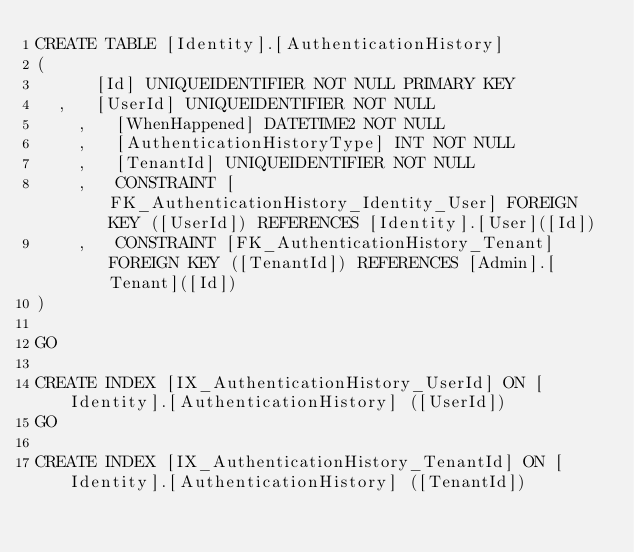Convert code to text. <code><loc_0><loc_0><loc_500><loc_500><_SQL_>CREATE TABLE [Identity].[AuthenticationHistory]
(
	    [Id] UNIQUEIDENTIFIER NOT NULL PRIMARY KEY
	,   [UserId] UNIQUEIDENTIFIER NOT NULL
    ,   [WhenHappened] DATETIME2 NOT NULL 
    ,   [AuthenticationHistoryType] INT NOT NULL
    ,   [TenantId] UNIQUEIDENTIFIER NOT NULL 
    ,   CONSTRAINT [FK_AuthenticationHistory_Identity_User] FOREIGN KEY ([UserId]) REFERENCES [Identity].[User]([Id])
    ,   CONSTRAINT [FK_AuthenticationHistory_Tenant] FOREIGN KEY ([TenantId]) REFERENCES [Admin].[Tenant]([Id])
)

GO

CREATE INDEX [IX_AuthenticationHistory_UserId] ON [Identity].[AuthenticationHistory] ([UserId])
GO

CREATE INDEX [IX_AuthenticationHistory_TenantId] ON [Identity].[AuthenticationHistory] ([TenantId])
</code> 